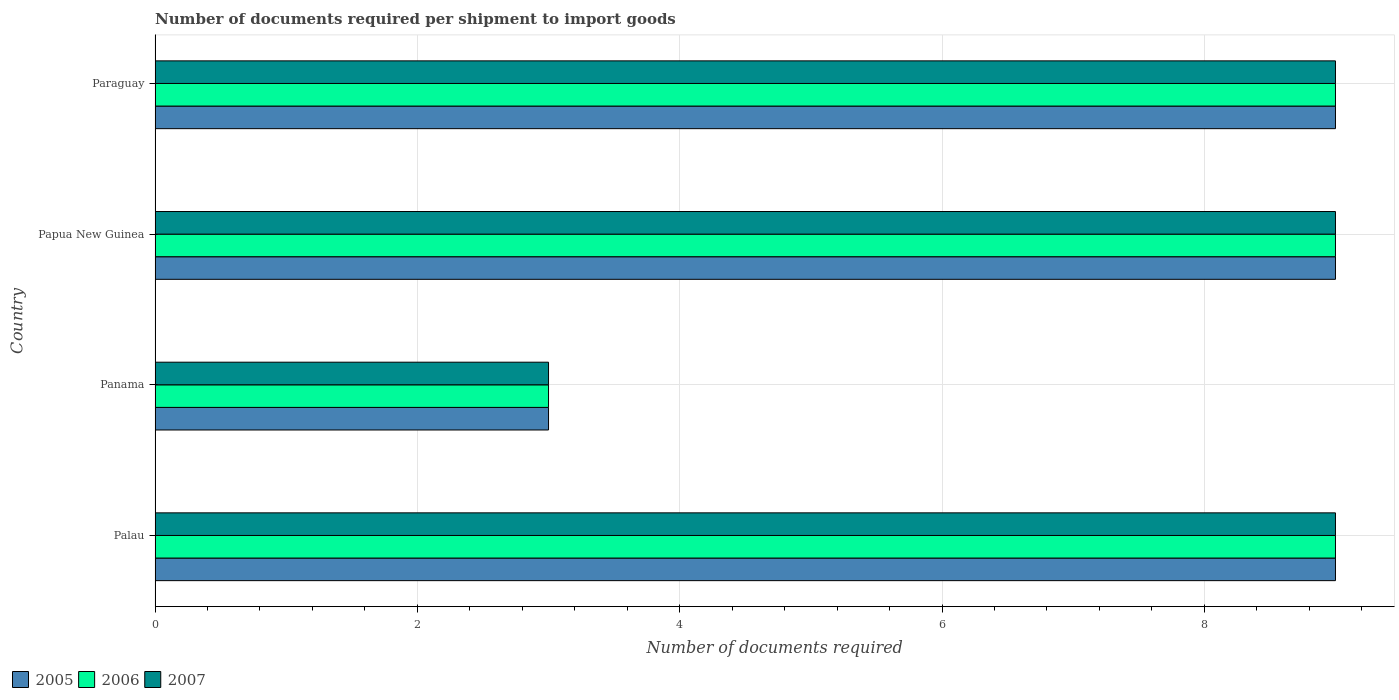How many different coloured bars are there?
Your response must be concise. 3. How many groups of bars are there?
Give a very brief answer. 4. Are the number of bars per tick equal to the number of legend labels?
Your response must be concise. Yes. Are the number of bars on each tick of the Y-axis equal?
Give a very brief answer. Yes. How many bars are there on the 3rd tick from the top?
Offer a terse response. 3. What is the label of the 2nd group of bars from the top?
Offer a terse response. Papua New Guinea. In which country was the number of documents required per shipment to import goods in 2007 maximum?
Offer a terse response. Palau. In which country was the number of documents required per shipment to import goods in 2005 minimum?
Ensure brevity in your answer.  Panama. What is the difference between the number of documents required per shipment to import goods in 2007 in Palau and that in Panama?
Make the answer very short. 6. What is the average number of documents required per shipment to import goods in 2007 per country?
Your answer should be compact. 7.5. What is the difference between the highest and the lowest number of documents required per shipment to import goods in 2006?
Provide a succinct answer. 6. Are all the bars in the graph horizontal?
Give a very brief answer. Yes. What is the difference between two consecutive major ticks on the X-axis?
Provide a succinct answer. 2. Does the graph contain any zero values?
Keep it short and to the point. No. Does the graph contain grids?
Your response must be concise. Yes. How many legend labels are there?
Ensure brevity in your answer.  3. How are the legend labels stacked?
Make the answer very short. Horizontal. What is the title of the graph?
Your answer should be very brief. Number of documents required per shipment to import goods. Does "2012" appear as one of the legend labels in the graph?
Offer a terse response. No. What is the label or title of the X-axis?
Provide a succinct answer. Number of documents required. What is the label or title of the Y-axis?
Make the answer very short. Country. What is the Number of documents required in 2006 in Palau?
Provide a succinct answer. 9. What is the Number of documents required in 2007 in Palau?
Ensure brevity in your answer.  9. What is the Number of documents required of 2006 in Panama?
Your response must be concise. 3. What is the Number of documents required in 2007 in Panama?
Your answer should be very brief. 3. What is the Number of documents required of 2005 in Papua New Guinea?
Offer a terse response. 9. What is the Number of documents required of 2006 in Papua New Guinea?
Keep it short and to the point. 9. What is the Number of documents required of 2007 in Papua New Guinea?
Make the answer very short. 9. What is the Number of documents required of 2005 in Paraguay?
Ensure brevity in your answer.  9. What is the Number of documents required of 2006 in Paraguay?
Offer a very short reply. 9. Across all countries, what is the maximum Number of documents required of 2005?
Provide a short and direct response. 9. Across all countries, what is the maximum Number of documents required in 2006?
Provide a short and direct response. 9. Across all countries, what is the maximum Number of documents required in 2007?
Your answer should be compact. 9. Across all countries, what is the minimum Number of documents required of 2007?
Provide a succinct answer. 3. What is the total Number of documents required in 2005 in the graph?
Ensure brevity in your answer.  30. What is the difference between the Number of documents required in 2005 in Palau and that in Panama?
Ensure brevity in your answer.  6. What is the difference between the Number of documents required of 2006 in Palau and that in Panama?
Provide a succinct answer. 6. What is the difference between the Number of documents required in 2005 in Panama and that in Papua New Guinea?
Provide a short and direct response. -6. What is the difference between the Number of documents required in 2006 in Panama and that in Papua New Guinea?
Your response must be concise. -6. What is the difference between the Number of documents required in 2007 in Panama and that in Papua New Guinea?
Keep it short and to the point. -6. What is the difference between the Number of documents required in 2005 in Panama and that in Paraguay?
Provide a short and direct response. -6. What is the difference between the Number of documents required in 2006 in Panama and that in Paraguay?
Keep it short and to the point. -6. What is the difference between the Number of documents required of 2007 in Panama and that in Paraguay?
Your answer should be compact. -6. What is the difference between the Number of documents required of 2006 in Papua New Guinea and that in Paraguay?
Provide a succinct answer. 0. What is the difference between the Number of documents required in 2007 in Papua New Guinea and that in Paraguay?
Make the answer very short. 0. What is the difference between the Number of documents required in 2005 in Palau and the Number of documents required in 2006 in Panama?
Your response must be concise. 6. What is the difference between the Number of documents required in 2005 in Palau and the Number of documents required in 2007 in Panama?
Your answer should be compact. 6. What is the difference between the Number of documents required of 2006 in Palau and the Number of documents required of 2007 in Panama?
Your answer should be compact. 6. What is the difference between the Number of documents required in 2005 in Palau and the Number of documents required in 2006 in Papua New Guinea?
Your response must be concise. 0. What is the difference between the Number of documents required of 2006 in Palau and the Number of documents required of 2007 in Papua New Guinea?
Your answer should be very brief. 0. What is the difference between the Number of documents required in 2005 in Palau and the Number of documents required in 2006 in Paraguay?
Make the answer very short. 0. What is the difference between the Number of documents required of 2005 in Panama and the Number of documents required of 2007 in Papua New Guinea?
Offer a terse response. -6. What is the difference between the Number of documents required in 2005 in Papua New Guinea and the Number of documents required in 2006 in Paraguay?
Offer a terse response. 0. What is the average Number of documents required of 2005 per country?
Give a very brief answer. 7.5. What is the average Number of documents required in 2006 per country?
Provide a succinct answer. 7.5. What is the average Number of documents required of 2007 per country?
Provide a succinct answer. 7.5. What is the difference between the Number of documents required in 2005 and Number of documents required in 2007 in Palau?
Make the answer very short. 0. What is the difference between the Number of documents required in 2006 and Number of documents required in 2007 in Panama?
Give a very brief answer. 0. What is the difference between the Number of documents required of 2006 and Number of documents required of 2007 in Papua New Guinea?
Ensure brevity in your answer.  0. What is the ratio of the Number of documents required of 2006 in Palau to that in Panama?
Give a very brief answer. 3. What is the ratio of the Number of documents required of 2005 in Palau to that in Papua New Guinea?
Offer a very short reply. 1. What is the ratio of the Number of documents required of 2006 in Palau to that in Papua New Guinea?
Provide a succinct answer. 1. What is the ratio of the Number of documents required in 2007 in Palau to that in Papua New Guinea?
Your answer should be very brief. 1. What is the ratio of the Number of documents required of 2006 in Palau to that in Paraguay?
Ensure brevity in your answer.  1. What is the ratio of the Number of documents required in 2005 in Panama to that in Papua New Guinea?
Make the answer very short. 0.33. What is the ratio of the Number of documents required of 2006 in Panama to that in Papua New Guinea?
Keep it short and to the point. 0.33. What is the ratio of the Number of documents required in 2005 in Panama to that in Paraguay?
Offer a very short reply. 0.33. What is the ratio of the Number of documents required of 2006 in Panama to that in Paraguay?
Ensure brevity in your answer.  0.33. What is the ratio of the Number of documents required in 2005 in Papua New Guinea to that in Paraguay?
Keep it short and to the point. 1. What is the ratio of the Number of documents required in 2006 in Papua New Guinea to that in Paraguay?
Offer a terse response. 1. What is the ratio of the Number of documents required in 2007 in Papua New Guinea to that in Paraguay?
Offer a very short reply. 1. What is the difference between the highest and the second highest Number of documents required of 2005?
Provide a short and direct response. 0. What is the difference between the highest and the lowest Number of documents required in 2005?
Keep it short and to the point. 6. What is the difference between the highest and the lowest Number of documents required of 2006?
Provide a short and direct response. 6. What is the difference between the highest and the lowest Number of documents required in 2007?
Provide a succinct answer. 6. 